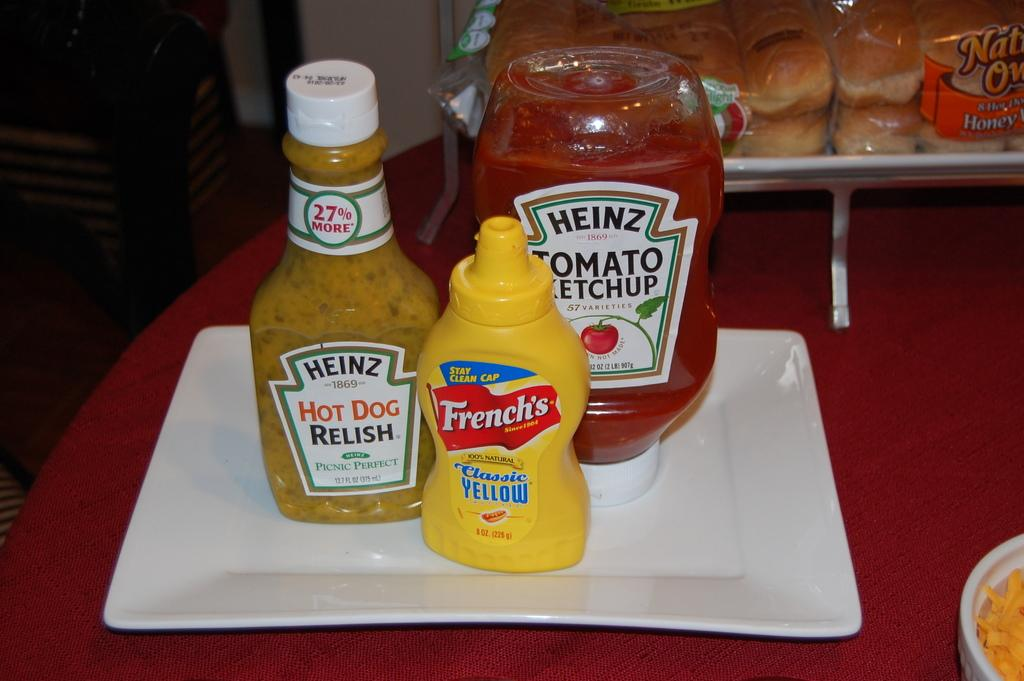<image>
Share a concise interpretation of the image provided. A bottle of Heinz ketchup mustard and relish. 